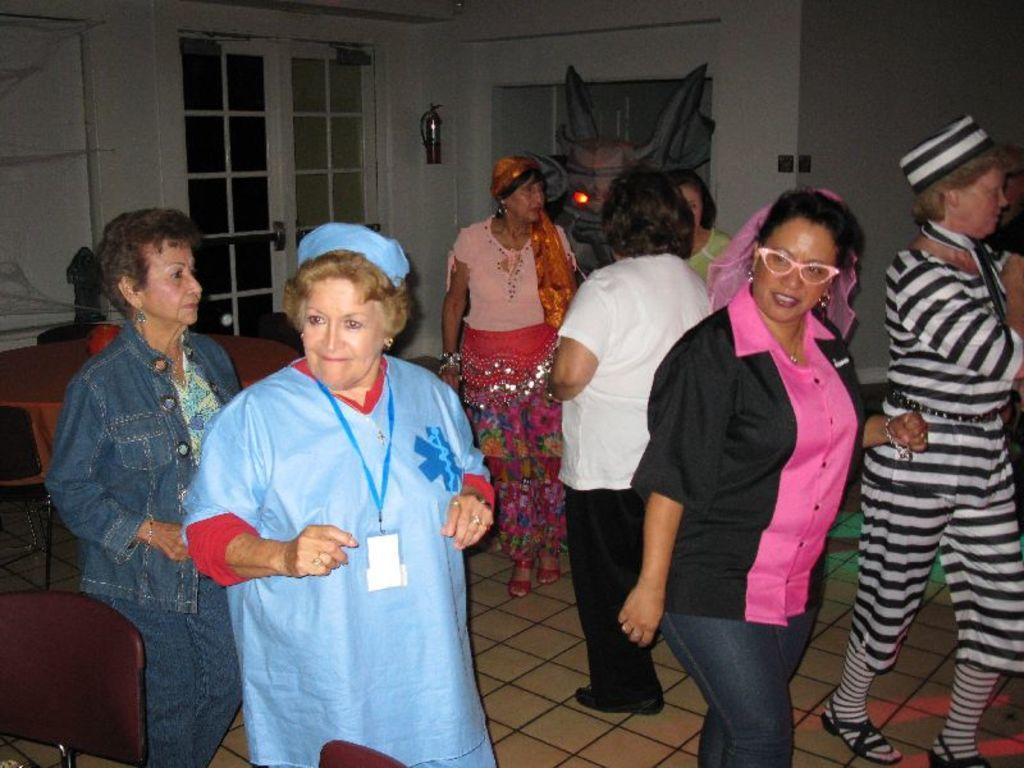What type of flooring is present in the room? The floor has tiles. Can you describe the people in the room? There are people in the room, but their specific actions or appearances are not mentioned in the facts. What piece of furniture is in the room? There is a table in the room. What safety device is present in the room? A fire extinguisher is present in the room. What type of seating is available in the room? There are chairs in the room. What request can be heard from the people in the room? There is no information about any requests being made by the people in the room, as the facts only mention their presence. What is the aftermath of the event in the room? There is no event mentioned in the facts, so it is impossible to describe its aftermath. 